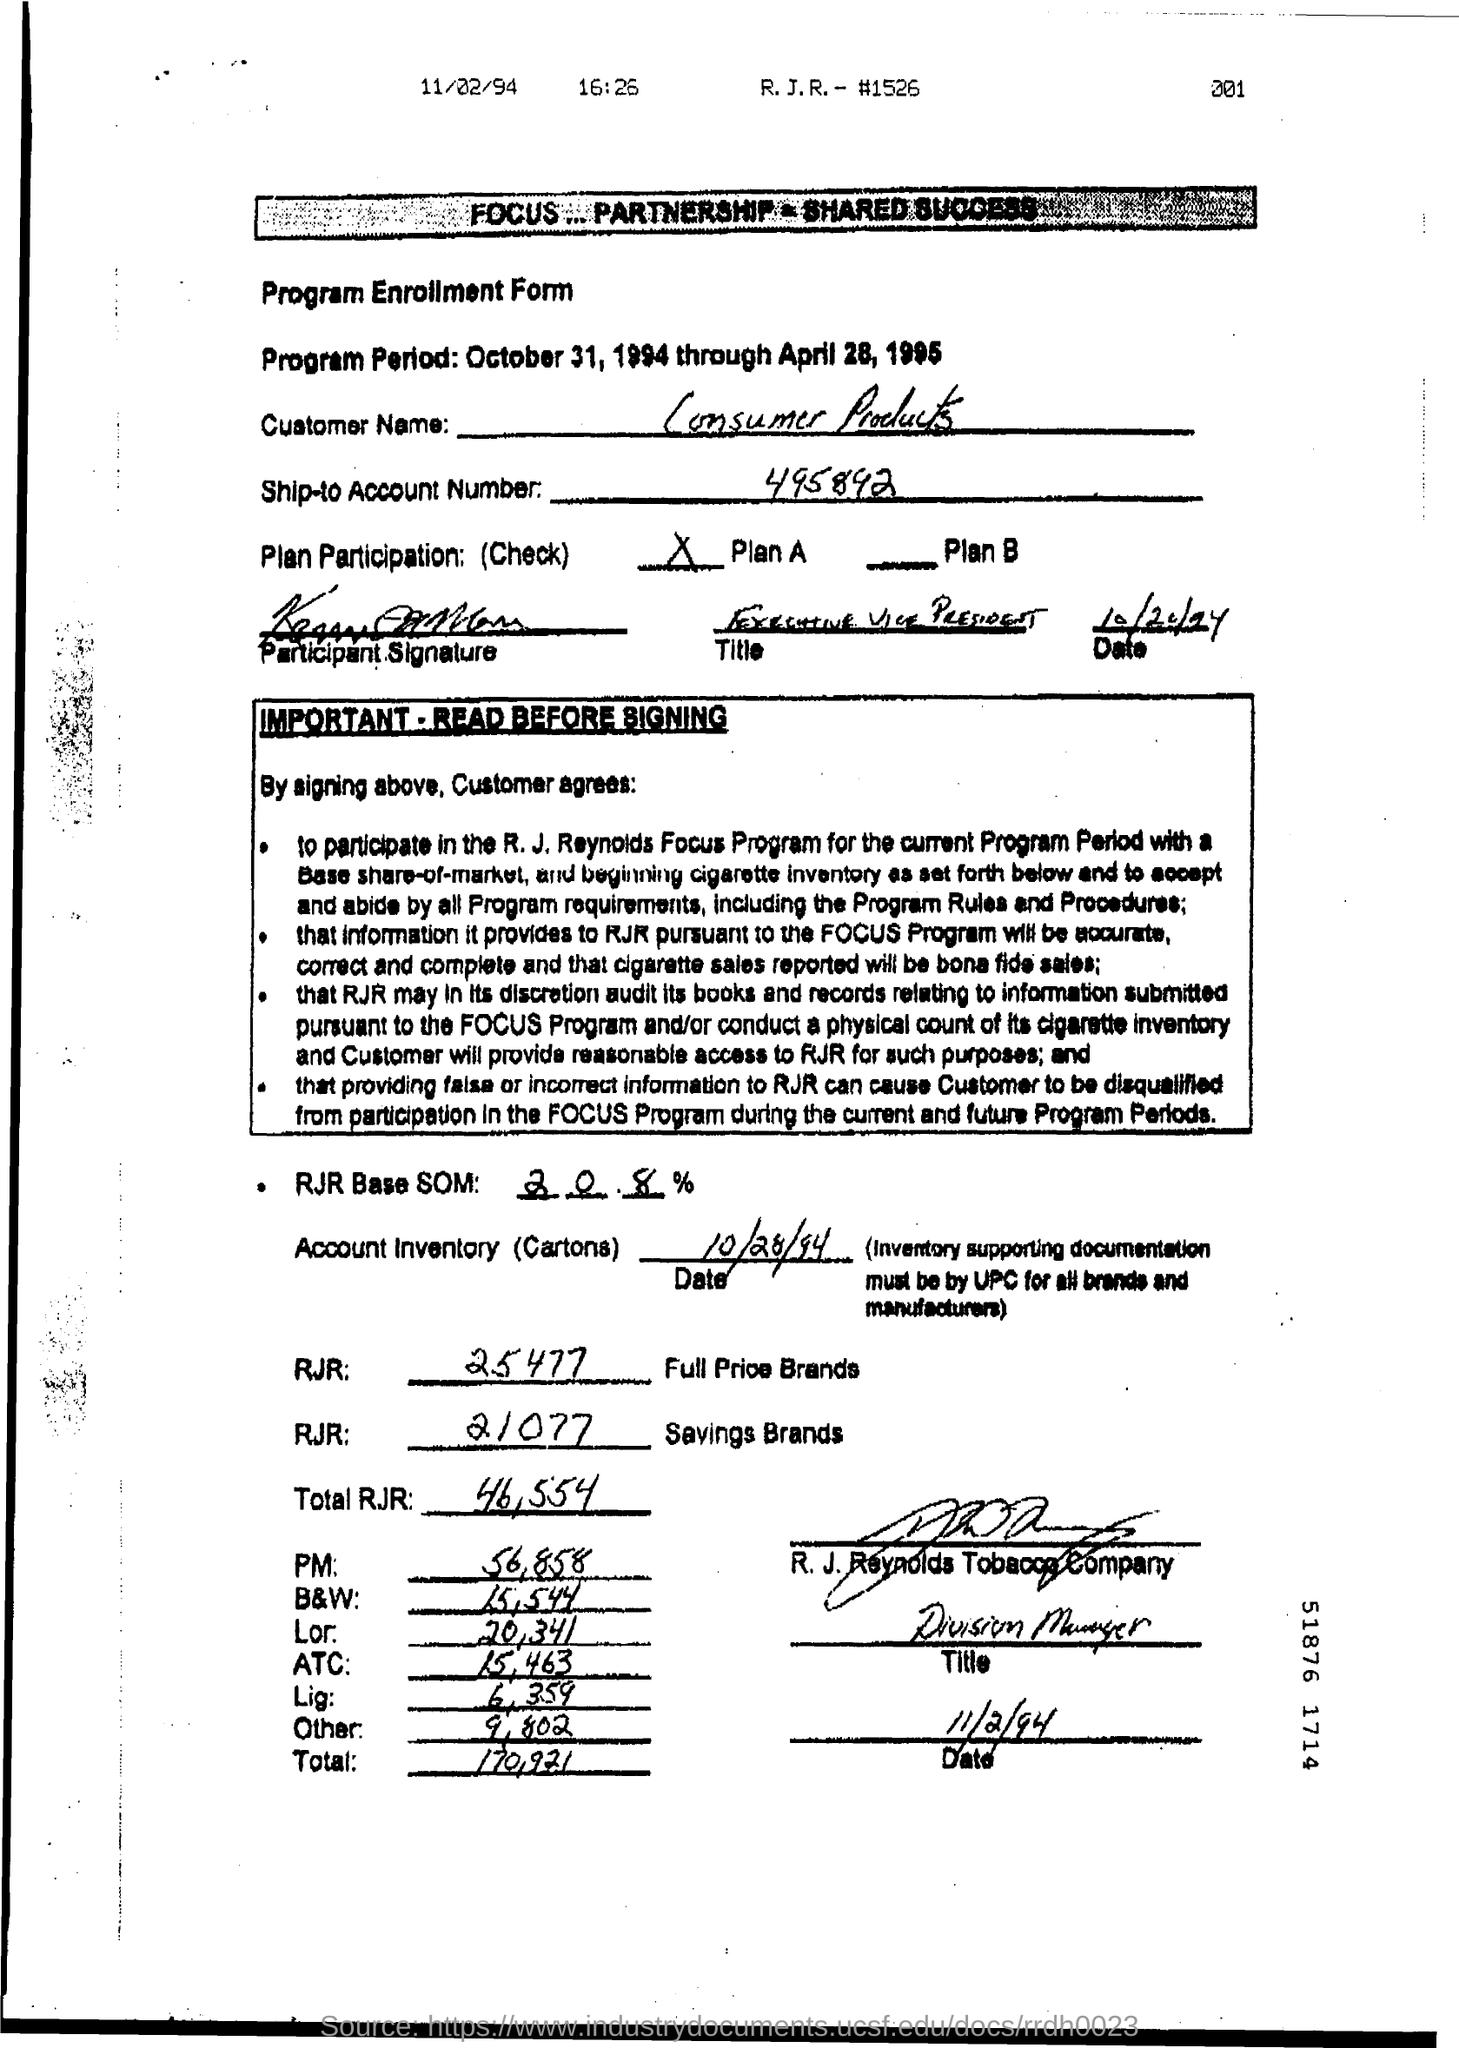What brands are included in the account inventory? The account inventory includes categories such as Full Price Brands and Savings Brands under R.J. Reynolds, and other brands like PM, B&W, Lor, ATC, Lig, and Others, with respective carton counts next to each. What signatures are present on the form? The form includes signatures from the participant, an executive vice president, and someone from the R. J. Reynolds Tobacco Company with the title of Division Manager, all dated 11/2/94. 